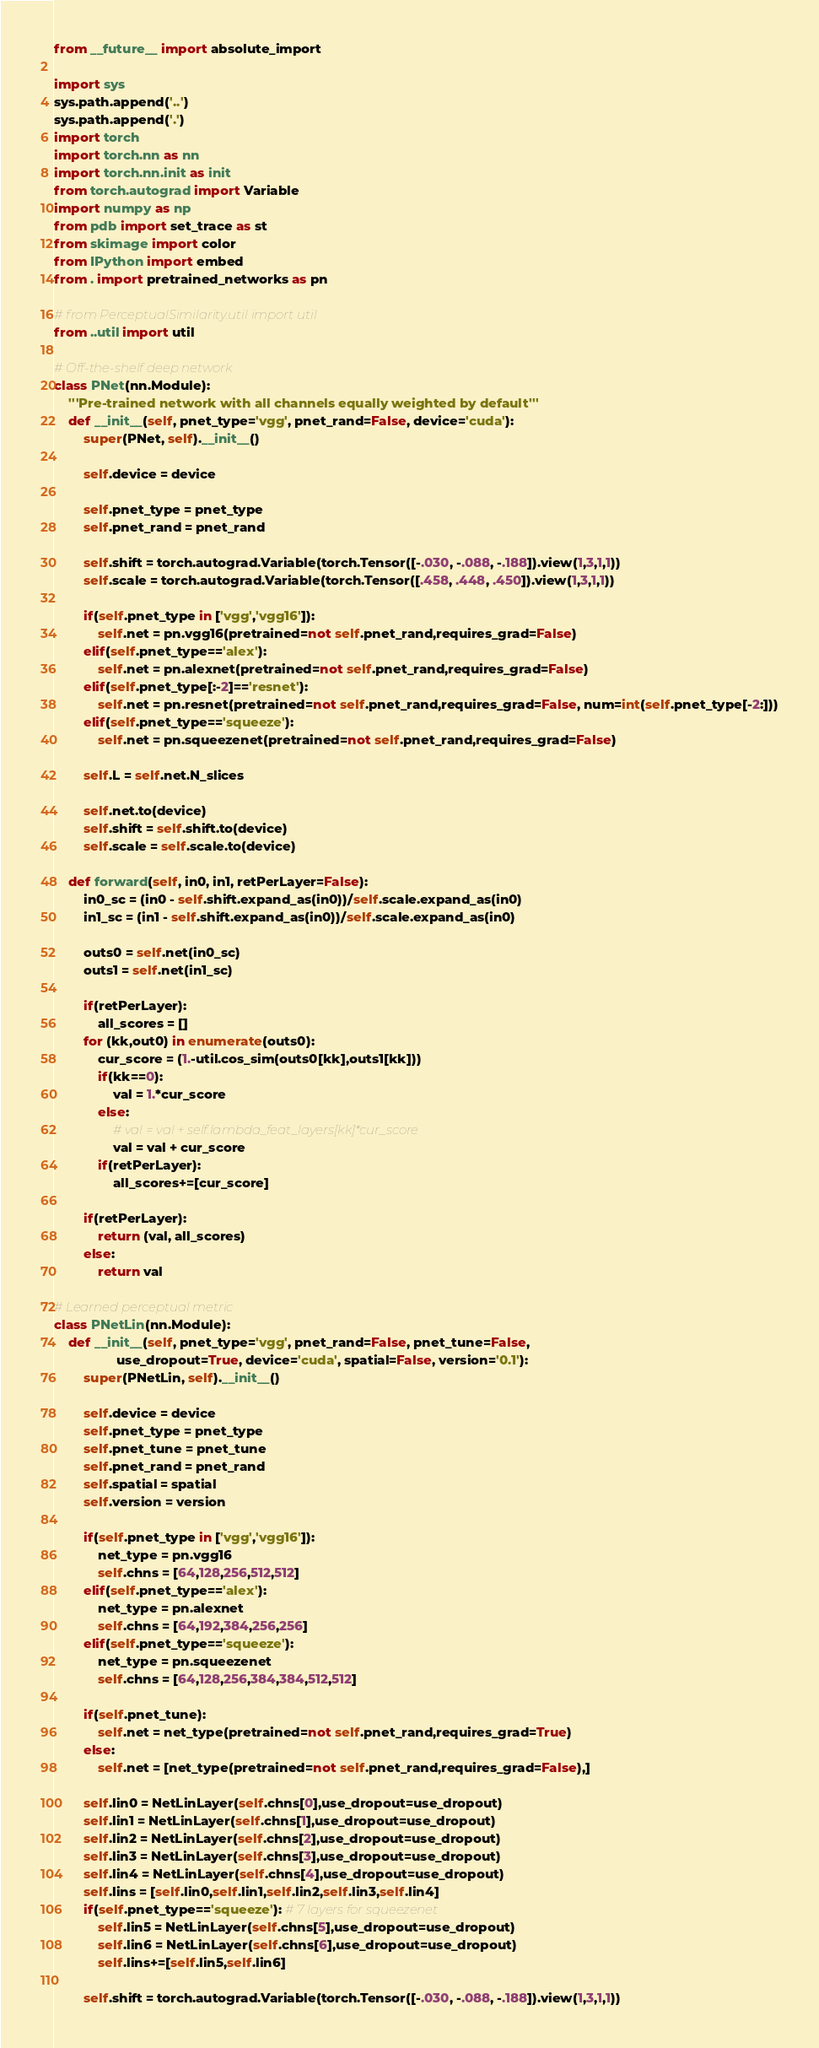Convert code to text. <code><loc_0><loc_0><loc_500><loc_500><_Python_>
from __future__ import absolute_import

import sys
sys.path.append('..')
sys.path.append('.')
import torch
import torch.nn as nn
import torch.nn.init as init
from torch.autograd import Variable
import numpy as np
from pdb import set_trace as st
from skimage import color
from IPython import embed
from . import pretrained_networks as pn

# from PerceptualSimilarity.util import util
from ..util import util

# Off-the-shelf deep network
class PNet(nn.Module):
    '''Pre-trained network with all channels equally weighted by default'''
    def __init__(self, pnet_type='vgg', pnet_rand=False, device='cuda'):
        super(PNet, self).__init__()

        self.device = device

        self.pnet_type = pnet_type
        self.pnet_rand = pnet_rand

        self.shift = torch.autograd.Variable(torch.Tensor([-.030, -.088, -.188]).view(1,3,1,1))
        self.scale = torch.autograd.Variable(torch.Tensor([.458, .448, .450]).view(1,3,1,1))

        if(self.pnet_type in ['vgg','vgg16']):
            self.net = pn.vgg16(pretrained=not self.pnet_rand,requires_grad=False)
        elif(self.pnet_type=='alex'):
            self.net = pn.alexnet(pretrained=not self.pnet_rand,requires_grad=False)
        elif(self.pnet_type[:-2]=='resnet'):
            self.net = pn.resnet(pretrained=not self.pnet_rand,requires_grad=False, num=int(self.pnet_type[-2:]))
        elif(self.pnet_type=='squeeze'):
            self.net = pn.squeezenet(pretrained=not self.pnet_rand,requires_grad=False)

        self.L = self.net.N_slices

        self.net.to(device)
        self.shift = self.shift.to(device)
        self.scale = self.scale.to(device)

    def forward(self, in0, in1, retPerLayer=False):
        in0_sc = (in0 - self.shift.expand_as(in0))/self.scale.expand_as(in0)
        in1_sc = (in1 - self.shift.expand_as(in0))/self.scale.expand_as(in0)

        outs0 = self.net(in0_sc)
        outs1 = self.net(in1_sc)

        if(retPerLayer):
            all_scores = []
        for (kk,out0) in enumerate(outs0):
            cur_score = (1.-util.cos_sim(outs0[kk],outs1[kk]))
            if(kk==0):
                val = 1.*cur_score
            else:
                # val = val + self.lambda_feat_layers[kk]*cur_score
                val = val + cur_score
            if(retPerLayer):
                all_scores+=[cur_score]

        if(retPerLayer):
            return (val, all_scores)
        else:
            return val

# Learned perceptual metric
class PNetLin(nn.Module):
    def __init__(self, pnet_type='vgg', pnet_rand=False, pnet_tune=False,
                 use_dropout=True, device='cuda', spatial=False, version='0.1'):
        super(PNetLin, self).__init__()

        self.device = device
        self.pnet_type = pnet_type
        self.pnet_tune = pnet_tune
        self.pnet_rand = pnet_rand
        self.spatial = spatial
        self.version = version

        if(self.pnet_type in ['vgg','vgg16']):
            net_type = pn.vgg16
            self.chns = [64,128,256,512,512]
        elif(self.pnet_type=='alex'):
            net_type = pn.alexnet
            self.chns = [64,192,384,256,256]
        elif(self.pnet_type=='squeeze'):
            net_type = pn.squeezenet
            self.chns = [64,128,256,384,384,512,512]

        if(self.pnet_tune):
            self.net = net_type(pretrained=not self.pnet_rand,requires_grad=True)
        else:
            self.net = [net_type(pretrained=not self.pnet_rand,requires_grad=False),]

        self.lin0 = NetLinLayer(self.chns[0],use_dropout=use_dropout)
        self.lin1 = NetLinLayer(self.chns[1],use_dropout=use_dropout)
        self.lin2 = NetLinLayer(self.chns[2],use_dropout=use_dropout)
        self.lin3 = NetLinLayer(self.chns[3],use_dropout=use_dropout)
        self.lin4 = NetLinLayer(self.chns[4],use_dropout=use_dropout)
        self.lins = [self.lin0,self.lin1,self.lin2,self.lin3,self.lin4]
        if(self.pnet_type=='squeeze'): # 7 layers for squeezenet
            self.lin5 = NetLinLayer(self.chns[5],use_dropout=use_dropout)
            self.lin6 = NetLinLayer(self.chns[6],use_dropout=use_dropout)
            self.lins+=[self.lin5,self.lin6]

        self.shift = torch.autograd.Variable(torch.Tensor([-.030, -.088, -.188]).view(1,3,1,1))</code> 